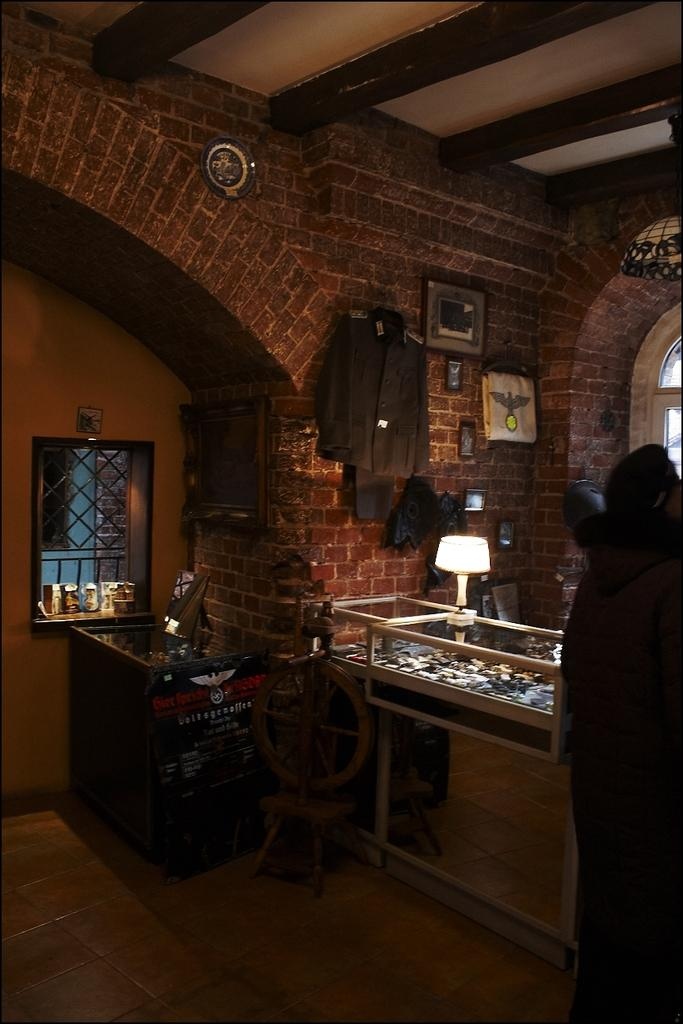Where was the image taken? The image was taken inside a room. What can be found in the room? There is a stall and a wall with many objects in the room. Can you describe the wall with many objects? The wall has a mirror and other objects on it. What part of the room is visible at the top of the image? The ceiling is visible at the top of the image. What type of cork is used to hold the instruments on the wall? There is no cork or instruments present in the image. What kind of brick is visible in the room? There is no brick visible in the room; the walls are not made of brick. 